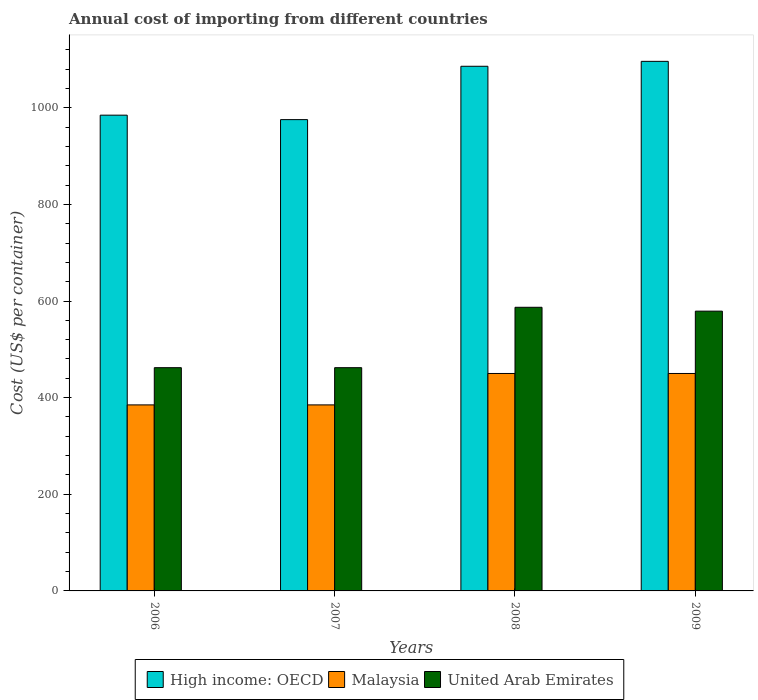How many groups of bars are there?
Keep it short and to the point. 4. Are the number of bars per tick equal to the number of legend labels?
Your answer should be compact. Yes. Are the number of bars on each tick of the X-axis equal?
Your response must be concise. Yes. How many bars are there on the 1st tick from the left?
Offer a terse response. 3. How many bars are there on the 2nd tick from the right?
Keep it short and to the point. 3. In how many cases, is the number of bars for a given year not equal to the number of legend labels?
Make the answer very short. 0. What is the total annual cost of importing in Malaysia in 2007?
Provide a succinct answer. 385. Across all years, what is the maximum total annual cost of importing in United Arab Emirates?
Your answer should be compact. 587. Across all years, what is the minimum total annual cost of importing in High income: OECD?
Offer a terse response. 975.38. In which year was the total annual cost of importing in Malaysia maximum?
Provide a succinct answer. 2008. What is the total total annual cost of importing in High income: OECD in the graph?
Your answer should be very brief. 4141.72. What is the difference between the total annual cost of importing in Malaysia in 2008 and that in 2009?
Provide a succinct answer. 0. What is the difference between the total annual cost of importing in High income: OECD in 2007 and the total annual cost of importing in United Arab Emirates in 2009?
Give a very brief answer. 396.38. What is the average total annual cost of importing in High income: OECD per year?
Make the answer very short. 1035.43. In the year 2006, what is the difference between the total annual cost of importing in Malaysia and total annual cost of importing in United Arab Emirates?
Offer a very short reply. -77. What is the ratio of the total annual cost of importing in Malaysia in 2007 to that in 2009?
Offer a terse response. 0.86. Is the difference between the total annual cost of importing in Malaysia in 2006 and 2007 greater than the difference between the total annual cost of importing in United Arab Emirates in 2006 and 2007?
Provide a succinct answer. No. What is the difference between the highest and the second highest total annual cost of importing in United Arab Emirates?
Make the answer very short. 8. What is the difference between the highest and the lowest total annual cost of importing in Malaysia?
Offer a terse response. 65. What does the 1st bar from the left in 2006 represents?
Provide a short and direct response. High income: OECD. What does the 3rd bar from the right in 2007 represents?
Ensure brevity in your answer.  High income: OECD. How many bars are there?
Ensure brevity in your answer.  12. Are all the bars in the graph horizontal?
Your answer should be compact. No. Where does the legend appear in the graph?
Offer a terse response. Bottom center. How are the legend labels stacked?
Offer a very short reply. Horizontal. What is the title of the graph?
Keep it short and to the point. Annual cost of importing from different countries. What is the label or title of the X-axis?
Make the answer very short. Years. What is the label or title of the Y-axis?
Your answer should be compact. Cost (US$ per container). What is the Cost (US$ per container) in High income: OECD in 2006?
Provide a succinct answer. 984.59. What is the Cost (US$ per container) of Malaysia in 2006?
Ensure brevity in your answer.  385. What is the Cost (US$ per container) of United Arab Emirates in 2006?
Your answer should be compact. 462. What is the Cost (US$ per container) in High income: OECD in 2007?
Your answer should be compact. 975.38. What is the Cost (US$ per container) in Malaysia in 2007?
Your answer should be very brief. 385. What is the Cost (US$ per container) of United Arab Emirates in 2007?
Ensure brevity in your answer.  462. What is the Cost (US$ per container) of High income: OECD in 2008?
Provide a succinct answer. 1085.78. What is the Cost (US$ per container) in Malaysia in 2008?
Keep it short and to the point. 450. What is the Cost (US$ per container) of United Arab Emirates in 2008?
Make the answer very short. 587. What is the Cost (US$ per container) in High income: OECD in 2009?
Make the answer very short. 1095.97. What is the Cost (US$ per container) of Malaysia in 2009?
Offer a terse response. 450. What is the Cost (US$ per container) in United Arab Emirates in 2009?
Make the answer very short. 579. Across all years, what is the maximum Cost (US$ per container) in High income: OECD?
Offer a very short reply. 1095.97. Across all years, what is the maximum Cost (US$ per container) of Malaysia?
Your response must be concise. 450. Across all years, what is the maximum Cost (US$ per container) of United Arab Emirates?
Keep it short and to the point. 587. Across all years, what is the minimum Cost (US$ per container) of High income: OECD?
Make the answer very short. 975.38. Across all years, what is the minimum Cost (US$ per container) of Malaysia?
Give a very brief answer. 385. Across all years, what is the minimum Cost (US$ per container) in United Arab Emirates?
Offer a terse response. 462. What is the total Cost (US$ per container) of High income: OECD in the graph?
Your response must be concise. 4141.72. What is the total Cost (US$ per container) of Malaysia in the graph?
Make the answer very short. 1670. What is the total Cost (US$ per container) in United Arab Emirates in the graph?
Give a very brief answer. 2090. What is the difference between the Cost (US$ per container) of High income: OECD in 2006 and that in 2007?
Give a very brief answer. 9.22. What is the difference between the Cost (US$ per container) of Malaysia in 2006 and that in 2007?
Your response must be concise. 0. What is the difference between the Cost (US$ per container) in United Arab Emirates in 2006 and that in 2007?
Make the answer very short. 0. What is the difference between the Cost (US$ per container) in High income: OECD in 2006 and that in 2008?
Your answer should be compact. -101.19. What is the difference between the Cost (US$ per container) of Malaysia in 2006 and that in 2008?
Offer a very short reply. -65. What is the difference between the Cost (US$ per container) in United Arab Emirates in 2006 and that in 2008?
Your answer should be compact. -125. What is the difference between the Cost (US$ per container) of High income: OECD in 2006 and that in 2009?
Ensure brevity in your answer.  -111.38. What is the difference between the Cost (US$ per container) in Malaysia in 2006 and that in 2009?
Provide a short and direct response. -65. What is the difference between the Cost (US$ per container) of United Arab Emirates in 2006 and that in 2009?
Offer a terse response. -117. What is the difference between the Cost (US$ per container) in High income: OECD in 2007 and that in 2008?
Keep it short and to the point. -110.41. What is the difference between the Cost (US$ per container) of Malaysia in 2007 and that in 2008?
Your answer should be very brief. -65. What is the difference between the Cost (US$ per container) in United Arab Emirates in 2007 and that in 2008?
Your answer should be compact. -125. What is the difference between the Cost (US$ per container) of High income: OECD in 2007 and that in 2009?
Provide a short and direct response. -120.59. What is the difference between the Cost (US$ per container) of Malaysia in 2007 and that in 2009?
Offer a terse response. -65. What is the difference between the Cost (US$ per container) of United Arab Emirates in 2007 and that in 2009?
Give a very brief answer. -117. What is the difference between the Cost (US$ per container) in High income: OECD in 2008 and that in 2009?
Ensure brevity in your answer.  -10.19. What is the difference between the Cost (US$ per container) of Malaysia in 2008 and that in 2009?
Offer a very short reply. 0. What is the difference between the Cost (US$ per container) in United Arab Emirates in 2008 and that in 2009?
Offer a very short reply. 8. What is the difference between the Cost (US$ per container) of High income: OECD in 2006 and the Cost (US$ per container) of Malaysia in 2007?
Offer a terse response. 599.59. What is the difference between the Cost (US$ per container) in High income: OECD in 2006 and the Cost (US$ per container) in United Arab Emirates in 2007?
Provide a short and direct response. 522.59. What is the difference between the Cost (US$ per container) in Malaysia in 2006 and the Cost (US$ per container) in United Arab Emirates in 2007?
Your response must be concise. -77. What is the difference between the Cost (US$ per container) in High income: OECD in 2006 and the Cost (US$ per container) in Malaysia in 2008?
Your answer should be very brief. 534.59. What is the difference between the Cost (US$ per container) in High income: OECD in 2006 and the Cost (US$ per container) in United Arab Emirates in 2008?
Make the answer very short. 397.59. What is the difference between the Cost (US$ per container) of Malaysia in 2006 and the Cost (US$ per container) of United Arab Emirates in 2008?
Offer a terse response. -202. What is the difference between the Cost (US$ per container) of High income: OECD in 2006 and the Cost (US$ per container) of Malaysia in 2009?
Your answer should be compact. 534.59. What is the difference between the Cost (US$ per container) of High income: OECD in 2006 and the Cost (US$ per container) of United Arab Emirates in 2009?
Your response must be concise. 405.59. What is the difference between the Cost (US$ per container) of Malaysia in 2006 and the Cost (US$ per container) of United Arab Emirates in 2009?
Ensure brevity in your answer.  -194. What is the difference between the Cost (US$ per container) of High income: OECD in 2007 and the Cost (US$ per container) of Malaysia in 2008?
Make the answer very short. 525.38. What is the difference between the Cost (US$ per container) in High income: OECD in 2007 and the Cost (US$ per container) in United Arab Emirates in 2008?
Give a very brief answer. 388.38. What is the difference between the Cost (US$ per container) of Malaysia in 2007 and the Cost (US$ per container) of United Arab Emirates in 2008?
Provide a succinct answer. -202. What is the difference between the Cost (US$ per container) in High income: OECD in 2007 and the Cost (US$ per container) in Malaysia in 2009?
Make the answer very short. 525.38. What is the difference between the Cost (US$ per container) in High income: OECD in 2007 and the Cost (US$ per container) in United Arab Emirates in 2009?
Provide a succinct answer. 396.38. What is the difference between the Cost (US$ per container) of Malaysia in 2007 and the Cost (US$ per container) of United Arab Emirates in 2009?
Offer a terse response. -194. What is the difference between the Cost (US$ per container) in High income: OECD in 2008 and the Cost (US$ per container) in Malaysia in 2009?
Your answer should be very brief. 635.78. What is the difference between the Cost (US$ per container) in High income: OECD in 2008 and the Cost (US$ per container) in United Arab Emirates in 2009?
Offer a very short reply. 506.78. What is the difference between the Cost (US$ per container) of Malaysia in 2008 and the Cost (US$ per container) of United Arab Emirates in 2009?
Provide a succinct answer. -129. What is the average Cost (US$ per container) of High income: OECD per year?
Your answer should be very brief. 1035.43. What is the average Cost (US$ per container) in Malaysia per year?
Your answer should be compact. 417.5. What is the average Cost (US$ per container) in United Arab Emirates per year?
Make the answer very short. 522.5. In the year 2006, what is the difference between the Cost (US$ per container) of High income: OECD and Cost (US$ per container) of Malaysia?
Ensure brevity in your answer.  599.59. In the year 2006, what is the difference between the Cost (US$ per container) of High income: OECD and Cost (US$ per container) of United Arab Emirates?
Offer a very short reply. 522.59. In the year 2006, what is the difference between the Cost (US$ per container) of Malaysia and Cost (US$ per container) of United Arab Emirates?
Ensure brevity in your answer.  -77. In the year 2007, what is the difference between the Cost (US$ per container) in High income: OECD and Cost (US$ per container) in Malaysia?
Give a very brief answer. 590.38. In the year 2007, what is the difference between the Cost (US$ per container) of High income: OECD and Cost (US$ per container) of United Arab Emirates?
Keep it short and to the point. 513.38. In the year 2007, what is the difference between the Cost (US$ per container) in Malaysia and Cost (US$ per container) in United Arab Emirates?
Provide a short and direct response. -77. In the year 2008, what is the difference between the Cost (US$ per container) in High income: OECD and Cost (US$ per container) in Malaysia?
Make the answer very short. 635.78. In the year 2008, what is the difference between the Cost (US$ per container) in High income: OECD and Cost (US$ per container) in United Arab Emirates?
Keep it short and to the point. 498.78. In the year 2008, what is the difference between the Cost (US$ per container) of Malaysia and Cost (US$ per container) of United Arab Emirates?
Your response must be concise. -137. In the year 2009, what is the difference between the Cost (US$ per container) of High income: OECD and Cost (US$ per container) of Malaysia?
Ensure brevity in your answer.  645.97. In the year 2009, what is the difference between the Cost (US$ per container) in High income: OECD and Cost (US$ per container) in United Arab Emirates?
Provide a short and direct response. 516.97. In the year 2009, what is the difference between the Cost (US$ per container) of Malaysia and Cost (US$ per container) of United Arab Emirates?
Ensure brevity in your answer.  -129. What is the ratio of the Cost (US$ per container) of High income: OECD in 2006 to that in 2007?
Give a very brief answer. 1.01. What is the ratio of the Cost (US$ per container) in Malaysia in 2006 to that in 2007?
Your response must be concise. 1. What is the ratio of the Cost (US$ per container) of High income: OECD in 2006 to that in 2008?
Your response must be concise. 0.91. What is the ratio of the Cost (US$ per container) of Malaysia in 2006 to that in 2008?
Provide a short and direct response. 0.86. What is the ratio of the Cost (US$ per container) of United Arab Emirates in 2006 to that in 2008?
Offer a terse response. 0.79. What is the ratio of the Cost (US$ per container) of High income: OECD in 2006 to that in 2009?
Keep it short and to the point. 0.9. What is the ratio of the Cost (US$ per container) in Malaysia in 2006 to that in 2009?
Your answer should be very brief. 0.86. What is the ratio of the Cost (US$ per container) in United Arab Emirates in 2006 to that in 2009?
Ensure brevity in your answer.  0.8. What is the ratio of the Cost (US$ per container) in High income: OECD in 2007 to that in 2008?
Your answer should be very brief. 0.9. What is the ratio of the Cost (US$ per container) in Malaysia in 2007 to that in 2008?
Provide a short and direct response. 0.86. What is the ratio of the Cost (US$ per container) of United Arab Emirates in 2007 to that in 2008?
Your response must be concise. 0.79. What is the ratio of the Cost (US$ per container) in High income: OECD in 2007 to that in 2009?
Offer a very short reply. 0.89. What is the ratio of the Cost (US$ per container) of Malaysia in 2007 to that in 2009?
Ensure brevity in your answer.  0.86. What is the ratio of the Cost (US$ per container) in United Arab Emirates in 2007 to that in 2009?
Your answer should be compact. 0.8. What is the ratio of the Cost (US$ per container) of Malaysia in 2008 to that in 2009?
Give a very brief answer. 1. What is the ratio of the Cost (US$ per container) in United Arab Emirates in 2008 to that in 2009?
Make the answer very short. 1.01. What is the difference between the highest and the second highest Cost (US$ per container) of High income: OECD?
Your answer should be compact. 10.19. What is the difference between the highest and the second highest Cost (US$ per container) of Malaysia?
Provide a succinct answer. 0. What is the difference between the highest and the lowest Cost (US$ per container) of High income: OECD?
Your answer should be compact. 120.59. What is the difference between the highest and the lowest Cost (US$ per container) of Malaysia?
Provide a succinct answer. 65. What is the difference between the highest and the lowest Cost (US$ per container) of United Arab Emirates?
Your response must be concise. 125. 